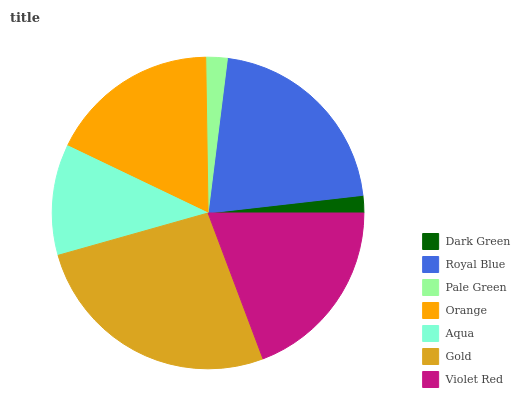Is Dark Green the minimum?
Answer yes or no. Yes. Is Gold the maximum?
Answer yes or no. Yes. Is Royal Blue the minimum?
Answer yes or no. No. Is Royal Blue the maximum?
Answer yes or no. No. Is Royal Blue greater than Dark Green?
Answer yes or no. Yes. Is Dark Green less than Royal Blue?
Answer yes or no. Yes. Is Dark Green greater than Royal Blue?
Answer yes or no. No. Is Royal Blue less than Dark Green?
Answer yes or no. No. Is Orange the high median?
Answer yes or no. Yes. Is Orange the low median?
Answer yes or no. Yes. Is Pale Green the high median?
Answer yes or no. No. Is Gold the low median?
Answer yes or no. No. 